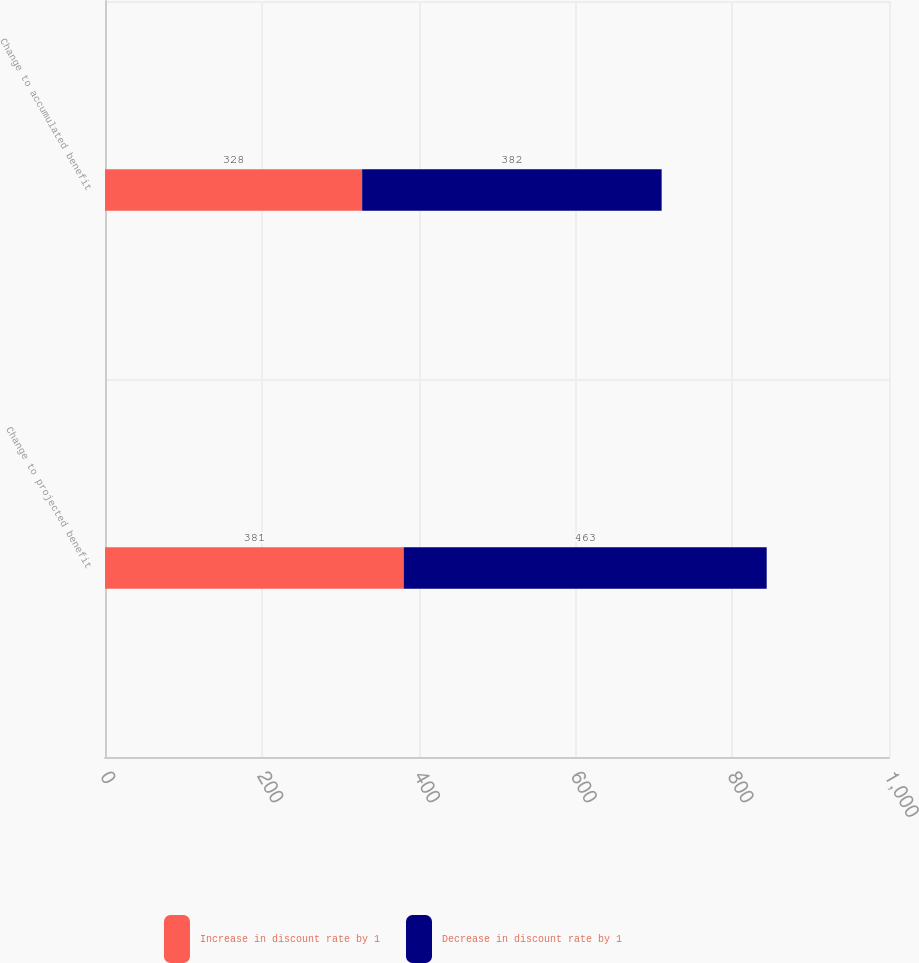Convert chart to OTSL. <chart><loc_0><loc_0><loc_500><loc_500><stacked_bar_chart><ecel><fcel>Change to projected benefit<fcel>Change to accumulated benefit<nl><fcel>Increase in discount rate by 1<fcel>381<fcel>328<nl><fcel>Decrease in discount rate by 1<fcel>463<fcel>382<nl></chart> 